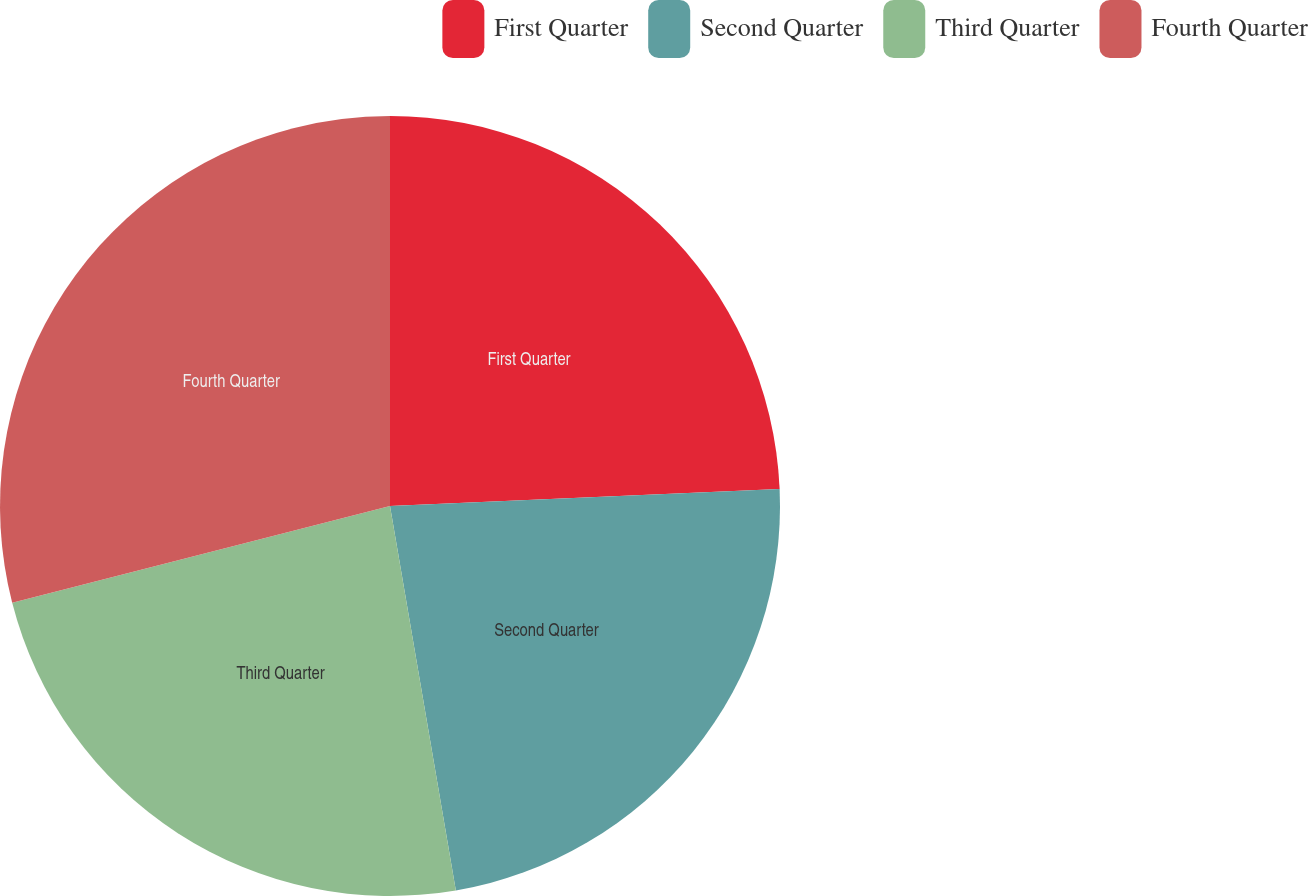Convert chart. <chart><loc_0><loc_0><loc_500><loc_500><pie_chart><fcel>First Quarter<fcel>Second Quarter<fcel>Third Quarter<fcel>Fourth Quarter<nl><fcel>24.31%<fcel>22.99%<fcel>23.71%<fcel>28.99%<nl></chart> 